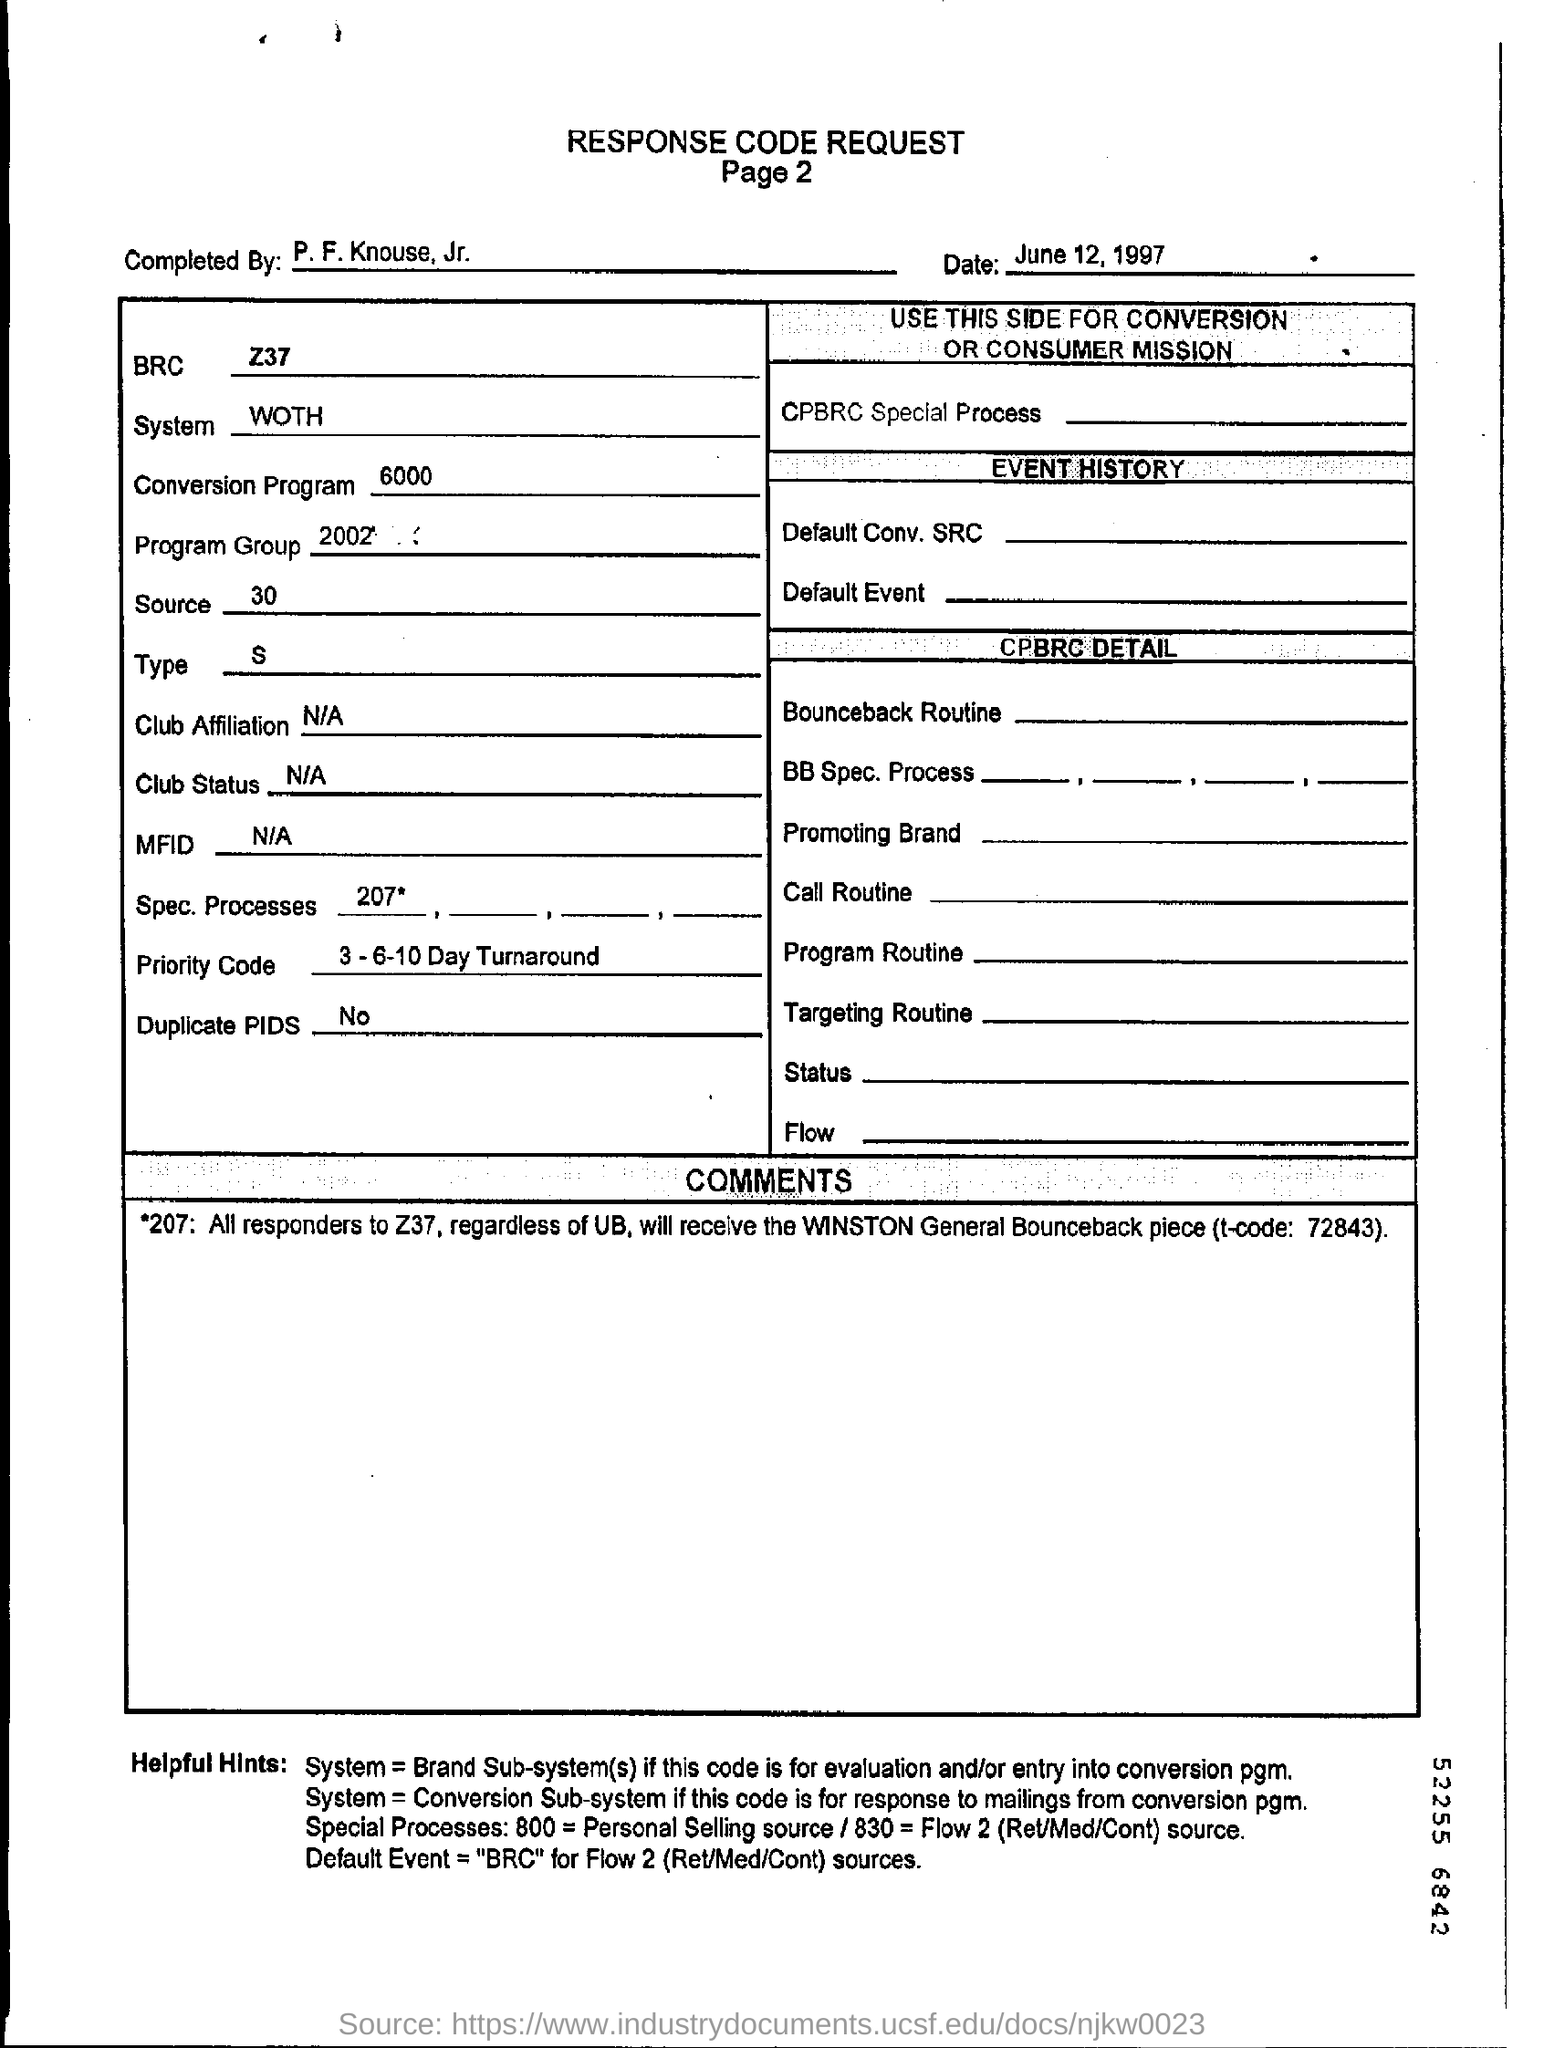Point out several critical features in this image. The system mentioned in the form is WOTH. 